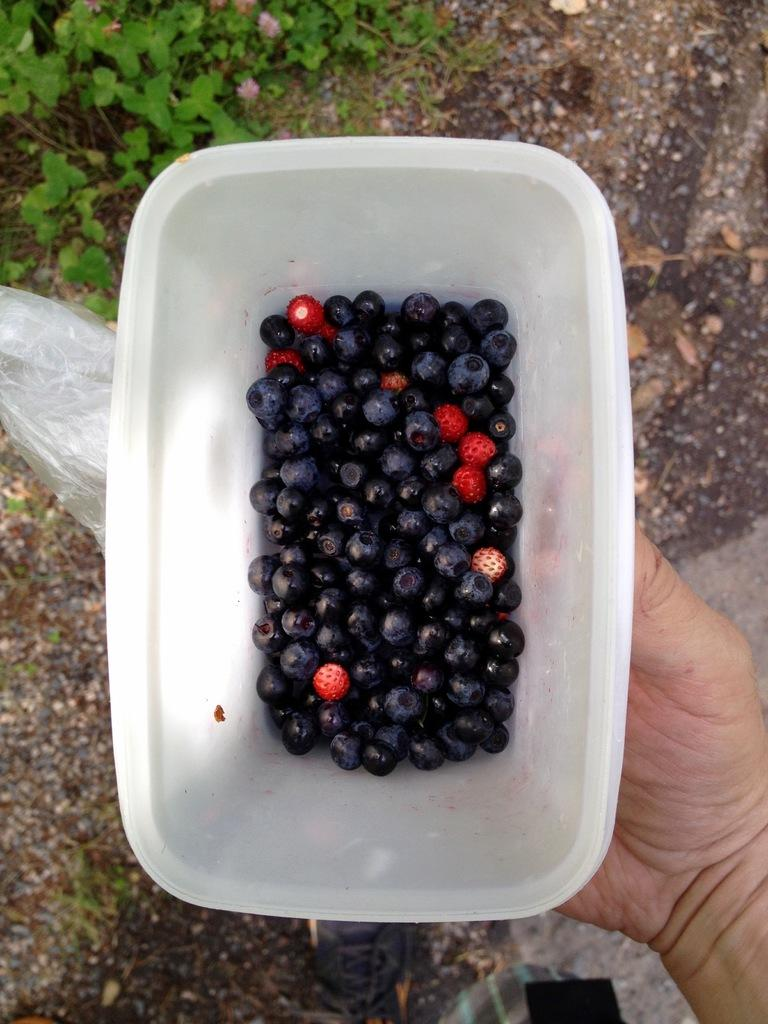What type of food is in the container in the image? There are berries in a container in the image. Who or what is holding the container in the image? The container is being held by a hand on the right side of the image. What type of vegetation is visible at the top of the image? Leaves are visible at the top of the image. What type of bell can be heard ringing in the image? There is no bell present in the image, and therefore no sound can be heard. 